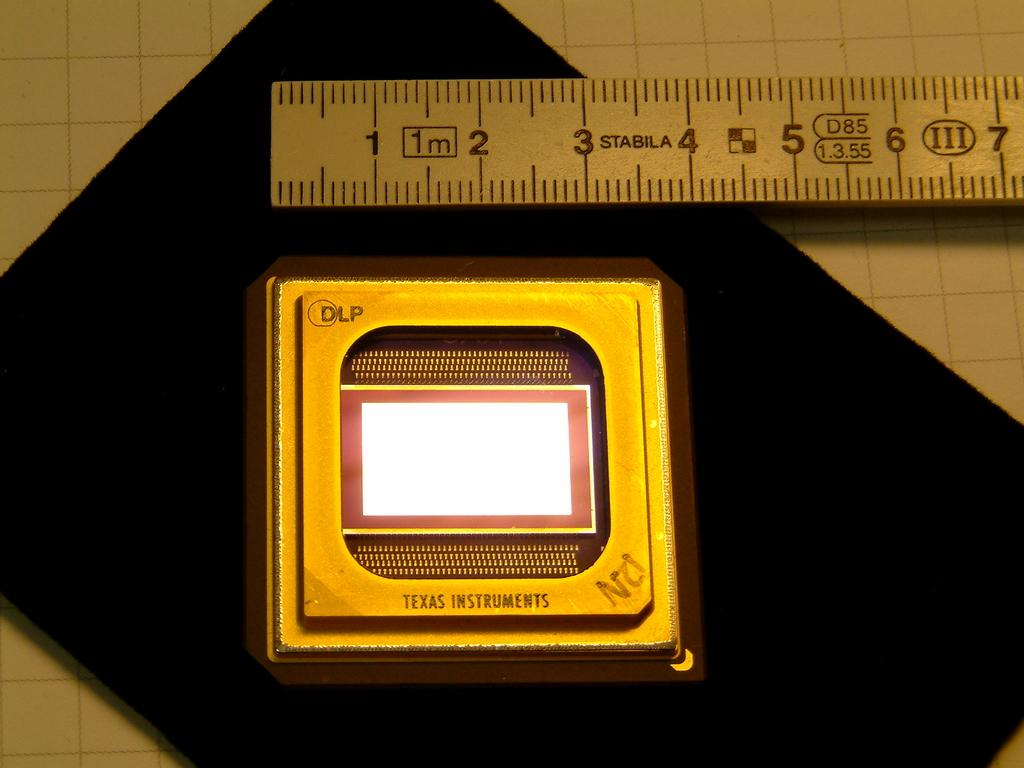Provide a one-sentence caption for the provided image. A STABILA ruler measures an object at just under 4 units. 